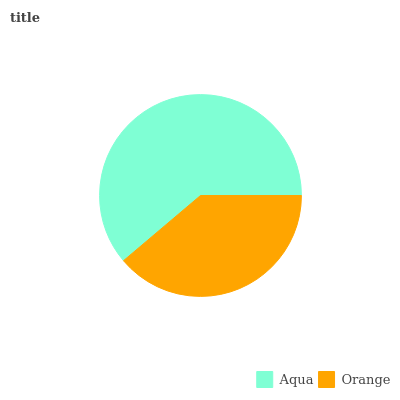Is Orange the minimum?
Answer yes or no. Yes. Is Aqua the maximum?
Answer yes or no. Yes. Is Orange the maximum?
Answer yes or no. No. Is Aqua greater than Orange?
Answer yes or no. Yes. Is Orange less than Aqua?
Answer yes or no. Yes. Is Orange greater than Aqua?
Answer yes or no. No. Is Aqua less than Orange?
Answer yes or no. No. Is Aqua the high median?
Answer yes or no. Yes. Is Orange the low median?
Answer yes or no. Yes. Is Orange the high median?
Answer yes or no. No. Is Aqua the low median?
Answer yes or no. No. 